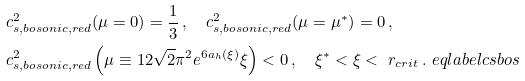Convert formula to latex. <formula><loc_0><loc_0><loc_500><loc_500>& c _ { s , b o s o n i c , r e d } ^ { 2 } ( \mu = 0 ) = \frac { 1 } { 3 } \, , \quad c _ { s , b o s o n i c , r e d } ^ { 2 } ( \mu = \mu ^ { * } ) = 0 \, , \\ & c _ { s , b o s o n i c , r e d } ^ { 2 } \left ( \mu \equiv 1 2 \sqrt { 2 } \pi ^ { 2 } e ^ { 6 a _ { h } ( \xi ) } \xi \right ) < 0 \, , \quad \xi ^ { * } < \xi < \ r _ { c r i t } \, . \ e q l a b e l { c s b o s }</formula> 